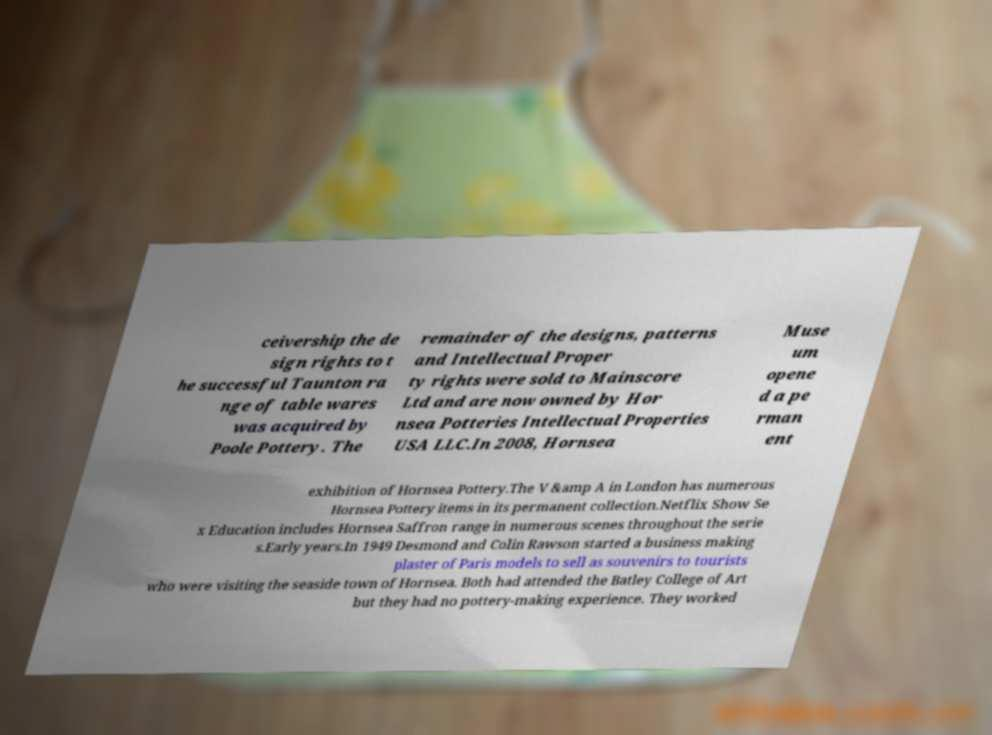Can you read and provide the text displayed in the image?This photo seems to have some interesting text. Can you extract and type it out for me? ceivership the de sign rights to t he successful Taunton ra nge of table wares was acquired by Poole Pottery. The remainder of the designs, patterns and Intellectual Proper ty rights were sold to Mainscore Ltd and are now owned by Hor nsea Potteries Intellectual Properties USA LLC.In 2008, Hornsea Muse um opene d a pe rman ent exhibition of Hornsea Pottery.The V &amp A in London has numerous Hornsea Pottery items in its permanent collection.Netflix Show Se x Education includes Hornsea Saffron range in numerous scenes throughout the serie s.Early years.In 1949 Desmond and Colin Rawson started a business making plaster of Paris models to sell as souvenirs to tourists who were visiting the seaside town of Hornsea. Both had attended the Batley College of Art but they had no pottery-making experience. They worked 